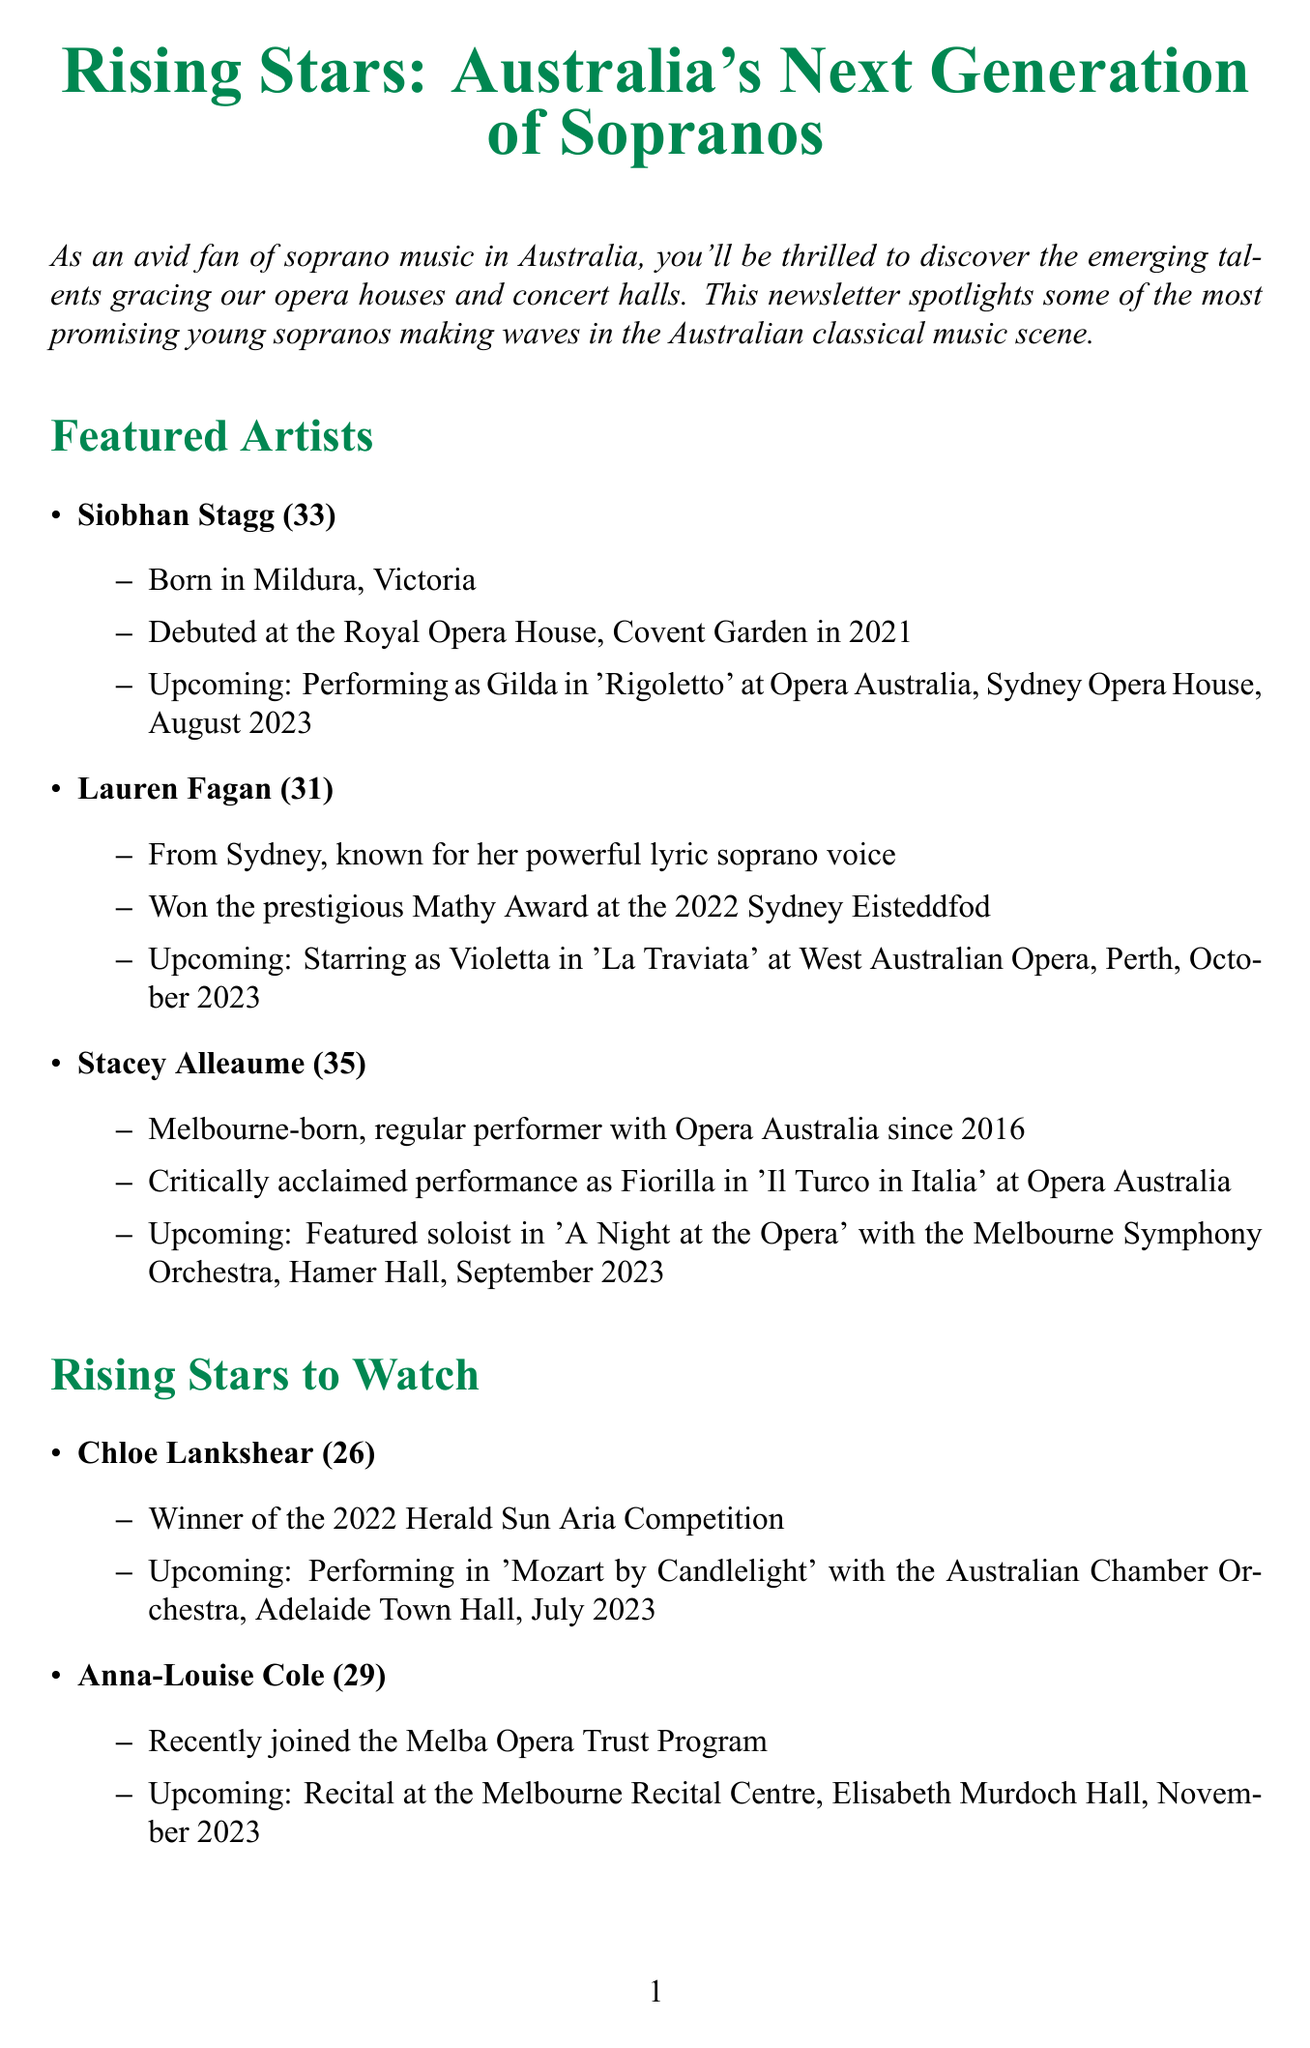What is the title of the newsletter? The title of the newsletter is provided at the beginning of the document as "Rising Stars: Australia's Next Generation of Sopranos".
Answer: Rising Stars: Australia's Next Generation of Sopranos Who is performing as Gilda in 'Rigoletto'? The document states that Siobhan Stagg will be performing as Gilda in 'Rigoletto' at Opera Australia.
Answer: Siobhan Stagg What award did Lauren Fagan win in 2022? The document notes that Lauren Fagan won the prestigious Mathy Award at the 2022 Sydney Eisteddfod.
Answer: Mathy Award When is the Australian Singing Competition taking place? The document indicates that the Australian Singing Competition is scheduled for September 15-17, 2023.
Answer: September 15-17, 2023 What notable achievement does Chloe Lankshear have? According to the document, Chloe Lankshear is the winner of the 2022 Herald Sun Aria Competition.
Answer: Winner of the 2022 Herald Sun Aria Competition What is Siobhan Stagg's career highlight? The document mentions that Siobhan Stagg's career highlight is performing at the BBC Proms in London.
Answer: Performing at the BBC Proms in London What venue will the recital by Anna-Louise Cole be held? Based on the document, Anna-Louise Cole's recital will be held at the Melbourne Recital Centre, Elisabeth Murdoch Hall.
Answer: Melbourne Recital Centre, Elisabeth Murdoch Hall What is the date of 'A Night at the Opera' performance? The upcoming performance of 'A Night at the Opera' with Stacey Alleaume is scheduled for September 2023.
Answer: September 2023 What is the quote from Siobhan Stagg in the spotlight interview? The quote by Siobhan Stagg highlights her feelings about the operatic talent in Australia.
Answer: "Australia has such a rich pool of operatic talent. I'm honoured to be part of this thriving community and to represent Australian artists on the world stage." 